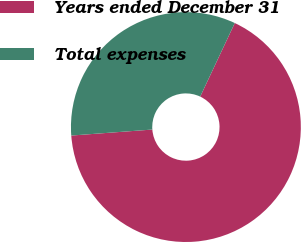Convert chart. <chart><loc_0><loc_0><loc_500><loc_500><pie_chart><fcel>Years ended December 31<fcel>Total expenses<nl><fcel>66.83%<fcel>33.17%<nl></chart> 